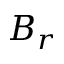Convert formula to latex. <formula><loc_0><loc_0><loc_500><loc_500>B _ { r }</formula> 